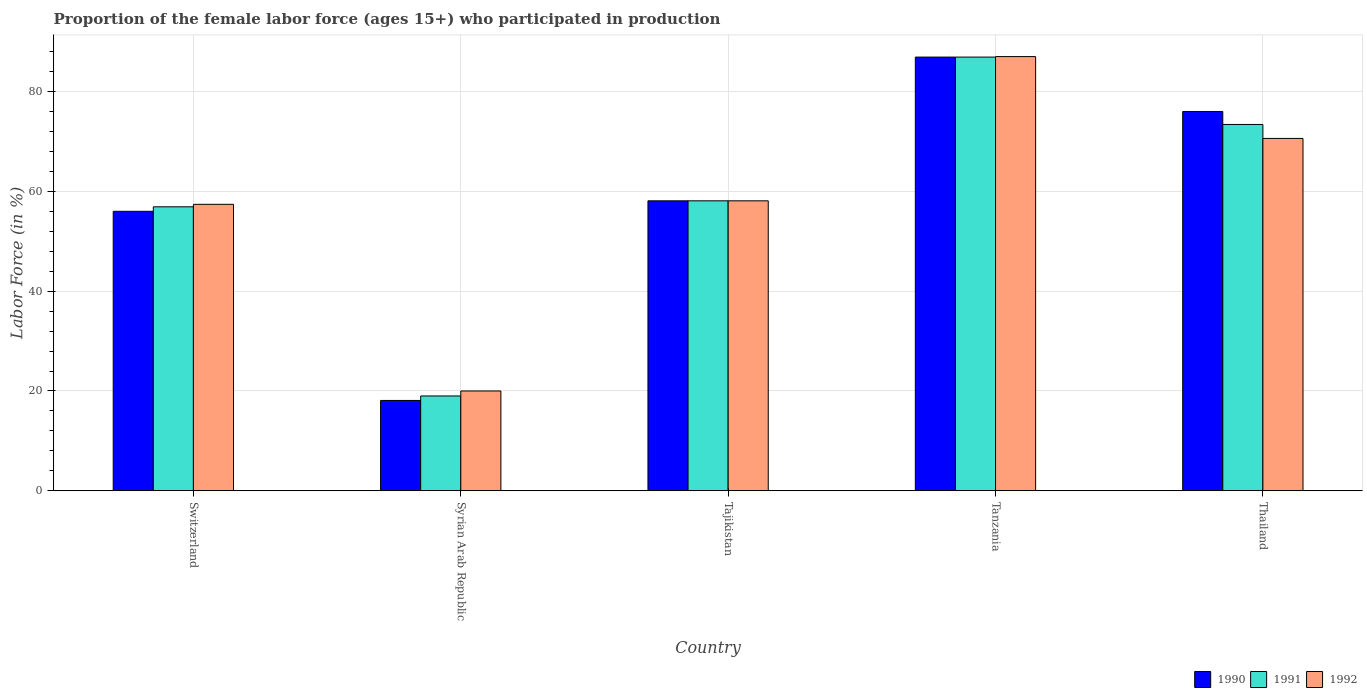How many different coloured bars are there?
Give a very brief answer. 3. How many bars are there on the 2nd tick from the left?
Make the answer very short. 3. How many bars are there on the 5th tick from the right?
Make the answer very short. 3. What is the label of the 3rd group of bars from the left?
Offer a very short reply. Tajikistan. In how many cases, is the number of bars for a given country not equal to the number of legend labels?
Offer a terse response. 0. What is the proportion of the female labor force who participated in production in 1991 in Tanzania?
Ensure brevity in your answer.  86.9. Across all countries, what is the maximum proportion of the female labor force who participated in production in 1990?
Provide a short and direct response. 86.9. Across all countries, what is the minimum proportion of the female labor force who participated in production in 1990?
Your response must be concise. 18.1. In which country was the proportion of the female labor force who participated in production in 1990 maximum?
Give a very brief answer. Tanzania. In which country was the proportion of the female labor force who participated in production in 1991 minimum?
Offer a terse response. Syrian Arab Republic. What is the total proportion of the female labor force who participated in production in 1990 in the graph?
Provide a short and direct response. 295.1. What is the difference between the proportion of the female labor force who participated in production in 1990 in Syrian Arab Republic and that in Thailand?
Your answer should be very brief. -57.9. What is the difference between the proportion of the female labor force who participated in production in 1991 in Thailand and the proportion of the female labor force who participated in production in 1990 in Syrian Arab Republic?
Provide a short and direct response. 55.3. What is the average proportion of the female labor force who participated in production in 1990 per country?
Offer a terse response. 59.02. What is the ratio of the proportion of the female labor force who participated in production in 1992 in Switzerland to that in Thailand?
Keep it short and to the point. 0.81. Is the proportion of the female labor force who participated in production in 1991 in Switzerland less than that in Tanzania?
Your answer should be compact. Yes. What is the difference between the highest and the second highest proportion of the female labor force who participated in production in 1992?
Offer a very short reply. -12.5. What is the difference between the highest and the lowest proportion of the female labor force who participated in production in 1990?
Offer a very short reply. 68.8. In how many countries, is the proportion of the female labor force who participated in production in 1991 greater than the average proportion of the female labor force who participated in production in 1991 taken over all countries?
Offer a terse response. 2. What does the 1st bar from the left in Tajikistan represents?
Ensure brevity in your answer.  1990. Are all the bars in the graph horizontal?
Give a very brief answer. No. Does the graph contain any zero values?
Your response must be concise. No. Does the graph contain grids?
Provide a succinct answer. Yes. What is the title of the graph?
Your answer should be very brief. Proportion of the female labor force (ages 15+) who participated in production. What is the label or title of the X-axis?
Ensure brevity in your answer.  Country. What is the label or title of the Y-axis?
Offer a terse response. Labor Force (in %). What is the Labor Force (in %) in 1990 in Switzerland?
Offer a very short reply. 56. What is the Labor Force (in %) of 1991 in Switzerland?
Offer a terse response. 56.9. What is the Labor Force (in %) in 1992 in Switzerland?
Keep it short and to the point. 57.4. What is the Labor Force (in %) in 1990 in Syrian Arab Republic?
Make the answer very short. 18.1. What is the Labor Force (in %) in 1991 in Syrian Arab Republic?
Ensure brevity in your answer.  19. What is the Labor Force (in %) in 1990 in Tajikistan?
Keep it short and to the point. 58.1. What is the Labor Force (in %) in 1991 in Tajikistan?
Keep it short and to the point. 58.1. What is the Labor Force (in %) in 1992 in Tajikistan?
Make the answer very short. 58.1. What is the Labor Force (in %) of 1990 in Tanzania?
Offer a very short reply. 86.9. What is the Labor Force (in %) in 1991 in Tanzania?
Your answer should be very brief. 86.9. What is the Labor Force (in %) of 1991 in Thailand?
Offer a very short reply. 73.4. What is the Labor Force (in %) in 1992 in Thailand?
Provide a short and direct response. 70.6. Across all countries, what is the maximum Labor Force (in %) in 1990?
Provide a succinct answer. 86.9. Across all countries, what is the maximum Labor Force (in %) in 1991?
Your response must be concise. 86.9. Across all countries, what is the maximum Labor Force (in %) of 1992?
Make the answer very short. 87. Across all countries, what is the minimum Labor Force (in %) of 1990?
Ensure brevity in your answer.  18.1. Across all countries, what is the minimum Labor Force (in %) in 1991?
Offer a terse response. 19. What is the total Labor Force (in %) of 1990 in the graph?
Keep it short and to the point. 295.1. What is the total Labor Force (in %) of 1991 in the graph?
Provide a succinct answer. 294.3. What is the total Labor Force (in %) in 1992 in the graph?
Your answer should be compact. 293.1. What is the difference between the Labor Force (in %) in 1990 in Switzerland and that in Syrian Arab Republic?
Your response must be concise. 37.9. What is the difference between the Labor Force (in %) in 1991 in Switzerland and that in Syrian Arab Republic?
Your answer should be compact. 37.9. What is the difference between the Labor Force (in %) in 1992 in Switzerland and that in Syrian Arab Republic?
Offer a terse response. 37.4. What is the difference between the Labor Force (in %) in 1990 in Switzerland and that in Tanzania?
Offer a terse response. -30.9. What is the difference between the Labor Force (in %) of 1992 in Switzerland and that in Tanzania?
Offer a terse response. -29.6. What is the difference between the Labor Force (in %) in 1991 in Switzerland and that in Thailand?
Keep it short and to the point. -16.5. What is the difference between the Labor Force (in %) of 1991 in Syrian Arab Republic and that in Tajikistan?
Your answer should be compact. -39.1. What is the difference between the Labor Force (in %) of 1992 in Syrian Arab Republic and that in Tajikistan?
Your response must be concise. -38.1. What is the difference between the Labor Force (in %) in 1990 in Syrian Arab Republic and that in Tanzania?
Keep it short and to the point. -68.8. What is the difference between the Labor Force (in %) in 1991 in Syrian Arab Republic and that in Tanzania?
Offer a very short reply. -67.9. What is the difference between the Labor Force (in %) in 1992 in Syrian Arab Republic and that in Tanzania?
Offer a very short reply. -67. What is the difference between the Labor Force (in %) in 1990 in Syrian Arab Republic and that in Thailand?
Your response must be concise. -57.9. What is the difference between the Labor Force (in %) in 1991 in Syrian Arab Republic and that in Thailand?
Your answer should be compact. -54.4. What is the difference between the Labor Force (in %) in 1992 in Syrian Arab Republic and that in Thailand?
Offer a very short reply. -50.6. What is the difference between the Labor Force (in %) in 1990 in Tajikistan and that in Tanzania?
Provide a succinct answer. -28.8. What is the difference between the Labor Force (in %) of 1991 in Tajikistan and that in Tanzania?
Provide a short and direct response. -28.8. What is the difference between the Labor Force (in %) in 1992 in Tajikistan and that in Tanzania?
Give a very brief answer. -28.9. What is the difference between the Labor Force (in %) in 1990 in Tajikistan and that in Thailand?
Give a very brief answer. -17.9. What is the difference between the Labor Force (in %) of 1991 in Tajikistan and that in Thailand?
Offer a very short reply. -15.3. What is the difference between the Labor Force (in %) in 1990 in Tanzania and that in Thailand?
Provide a succinct answer. 10.9. What is the difference between the Labor Force (in %) of 1991 in Tanzania and that in Thailand?
Keep it short and to the point. 13.5. What is the difference between the Labor Force (in %) in 1990 in Switzerland and the Labor Force (in %) in 1992 in Syrian Arab Republic?
Your answer should be compact. 36. What is the difference between the Labor Force (in %) in 1991 in Switzerland and the Labor Force (in %) in 1992 in Syrian Arab Republic?
Offer a very short reply. 36.9. What is the difference between the Labor Force (in %) of 1990 in Switzerland and the Labor Force (in %) of 1991 in Tanzania?
Provide a short and direct response. -30.9. What is the difference between the Labor Force (in %) of 1990 in Switzerland and the Labor Force (in %) of 1992 in Tanzania?
Provide a short and direct response. -31. What is the difference between the Labor Force (in %) of 1991 in Switzerland and the Labor Force (in %) of 1992 in Tanzania?
Offer a terse response. -30.1. What is the difference between the Labor Force (in %) of 1990 in Switzerland and the Labor Force (in %) of 1991 in Thailand?
Give a very brief answer. -17.4. What is the difference between the Labor Force (in %) of 1990 in Switzerland and the Labor Force (in %) of 1992 in Thailand?
Provide a succinct answer. -14.6. What is the difference between the Labor Force (in %) in 1991 in Switzerland and the Labor Force (in %) in 1992 in Thailand?
Your answer should be compact. -13.7. What is the difference between the Labor Force (in %) in 1990 in Syrian Arab Republic and the Labor Force (in %) in 1991 in Tajikistan?
Provide a succinct answer. -40. What is the difference between the Labor Force (in %) of 1991 in Syrian Arab Republic and the Labor Force (in %) of 1992 in Tajikistan?
Offer a terse response. -39.1. What is the difference between the Labor Force (in %) in 1990 in Syrian Arab Republic and the Labor Force (in %) in 1991 in Tanzania?
Keep it short and to the point. -68.8. What is the difference between the Labor Force (in %) of 1990 in Syrian Arab Republic and the Labor Force (in %) of 1992 in Tanzania?
Provide a succinct answer. -68.9. What is the difference between the Labor Force (in %) in 1991 in Syrian Arab Republic and the Labor Force (in %) in 1992 in Tanzania?
Provide a short and direct response. -68. What is the difference between the Labor Force (in %) of 1990 in Syrian Arab Republic and the Labor Force (in %) of 1991 in Thailand?
Give a very brief answer. -55.3. What is the difference between the Labor Force (in %) of 1990 in Syrian Arab Republic and the Labor Force (in %) of 1992 in Thailand?
Provide a short and direct response. -52.5. What is the difference between the Labor Force (in %) of 1991 in Syrian Arab Republic and the Labor Force (in %) of 1992 in Thailand?
Keep it short and to the point. -51.6. What is the difference between the Labor Force (in %) of 1990 in Tajikistan and the Labor Force (in %) of 1991 in Tanzania?
Give a very brief answer. -28.8. What is the difference between the Labor Force (in %) of 1990 in Tajikistan and the Labor Force (in %) of 1992 in Tanzania?
Provide a short and direct response. -28.9. What is the difference between the Labor Force (in %) in 1991 in Tajikistan and the Labor Force (in %) in 1992 in Tanzania?
Give a very brief answer. -28.9. What is the difference between the Labor Force (in %) of 1990 in Tajikistan and the Labor Force (in %) of 1991 in Thailand?
Ensure brevity in your answer.  -15.3. What is the difference between the Labor Force (in %) of 1990 in Tajikistan and the Labor Force (in %) of 1992 in Thailand?
Your response must be concise. -12.5. What is the difference between the Labor Force (in %) in 1991 in Tajikistan and the Labor Force (in %) in 1992 in Thailand?
Your response must be concise. -12.5. What is the difference between the Labor Force (in %) of 1990 in Tanzania and the Labor Force (in %) of 1991 in Thailand?
Provide a succinct answer. 13.5. What is the difference between the Labor Force (in %) in 1990 in Tanzania and the Labor Force (in %) in 1992 in Thailand?
Offer a terse response. 16.3. What is the difference between the Labor Force (in %) of 1991 in Tanzania and the Labor Force (in %) of 1992 in Thailand?
Give a very brief answer. 16.3. What is the average Labor Force (in %) in 1990 per country?
Provide a short and direct response. 59.02. What is the average Labor Force (in %) in 1991 per country?
Make the answer very short. 58.86. What is the average Labor Force (in %) in 1992 per country?
Give a very brief answer. 58.62. What is the difference between the Labor Force (in %) in 1990 and Labor Force (in %) in 1991 in Switzerland?
Your answer should be very brief. -0.9. What is the difference between the Labor Force (in %) in 1990 and Labor Force (in %) in 1992 in Switzerland?
Your response must be concise. -1.4. What is the difference between the Labor Force (in %) of 1991 and Labor Force (in %) of 1992 in Switzerland?
Offer a very short reply. -0.5. What is the difference between the Labor Force (in %) of 1990 and Labor Force (in %) of 1992 in Syrian Arab Republic?
Keep it short and to the point. -1.9. What is the difference between the Labor Force (in %) of 1990 and Labor Force (in %) of 1992 in Tajikistan?
Offer a very short reply. 0. What is the difference between the Labor Force (in %) of 1991 and Labor Force (in %) of 1992 in Tajikistan?
Ensure brevity in your answer.  0. What is the difference between the Labor Force (in %) in 1990 and Labor Force (in %) in 1991 in Tanzania?
Your response must be concise. 0. What is the ratio of the Labor Force (in %) in 1990 in Switzerland to that in Syrian Arab Republic?
Give a very brief answer. 3.09. What is the ratio of the Labor Force (in %) of 1991 in Switzerland to that in Syrian Arab Republic?
Your response must be concise. 2.99. What is the ratio of the Labor Force (in %) in 1992 in Switzerland to that in Syrian Arab Republic?
Give a very brief answer. 2.87. What is the ratio of the Labor Force (in %) in 1990 in Switzerland to that in Tajikistan?
Your response must be concise. 0.96. What is the ratio of the Labor Force (in %) of 1991 in Switzerland to that in Tajikistan?
Offer a very short reply. 0.98. What is the ratio of the Labor Force (in %) in 1992 in Switzerland to that in Tajikistan?
Your answer should be compact. 0.99. What is the ratio of the Labor Force (in %) of 1990 in Switzerland to that in Tanzania?
Your response must be concise. 0.64. What is the ratio of the Labor Force (in %) in 1991 in Switzerland to that in Tanzania?
Offer a very short reply. 0.65. What is the ratio of the Labor Force (in %) of 1992 in Switzerland to that in Tanzania?
Keep it short and to the point. 0.66. What is the ratio of the Labor Force (in %) in 1990 in Switzerland to that in Thailand?
Give a very brief answer. 0.74. What is the ratio of the Labor Force (in %) in 1991 in Switzerland to that in Thailand?
Offer a terse response. 0.78. What is the ratio of the Labor Force (in %) of 1992 in Switzerland to that in Thailand?
Give a very brief answer. 0.81. What is the ratio of the Labor Force (in %) of 1990 in Syrian Arab Republic to that in Tajikistan?
Keep it short and to the point. 0.31. What is the ratio of the Labor Force (in %) in 1991 in Syrian Arab Republic to that in Tajikistan?
Provide a succinct answer. 0.33. What is the ratio of the Labor Force (in %) in 1992 in Syrian Arab Republic to that in Tajikistan?
Your answer should be very brief. 0.34. What is the ratio of the Labor Force (in %) in 1990 in Syrian Arab Republic to that in Tanzania?
Provide a succinct answer. 0.21. What is the ratio of the Labor Force (in %) of 1991 in Syrian Arab Republic to that in Tanzania?
Offer a very short reply. 0.22. What is the ratio of the Labor Force (in %) of 1992 in Syrian Arab Republic to that in Tanzania?
Give a very brief answer. 0.23. What is the ratio of the Labor Force (in %) of 1990 in Syrian Arab Republic to that in Thailand?
Offer a very short reply. 0.24. What is the ratio of the Labor Force (in %) in 1991 in Syrian Arab Republic to that in Thailand?
Ensure brevity in your answer.  0.26. What is the ratio of the Labor Force (in %) in 1992 in Syrian Arab Republic to that in Thailand?
Keep it short and to the point. 0.28. What is the ratio of the Labor Force (in %) in 1990 in Tajikistan to that in Tanzania?
Provide a short and direct response. 0.67. What is the ratio of the Labor Force (in %) in 1991 in Tajikistan to that in Tanzania?
Your answer should be compact. 0.67. What is the ratio of the Labor Force (in %) in 1992 in Tajikistan to that in Tanzania?
Your response must be concise. 0.67. What is the ratio of the Labor Force (in %) in 1990 in Tajikistan to that in Thailand?
Your response must be concise. 0.76. What is the ratio of the Labor Force (in %) in 1991 in Tajikistan to that in Thailand?
Offer a terse response. 0.79. What is the ratio of the Labor Force (in %) in 1992 in Tajikistan to that in Thailand?
Your answer should be very brief. 0.82. What is the ratio of the Labor Force (in %) in 1990 in Tanzania to that in Thailand?
Offer a very short reply. 1.14. What is the ratio of the Labor Force (in %) in 1991 in Tanzania to that in Thailand?
Offer a very short reply. 1.18. What is the ratio of the Labor Force (in %) in 1992 in Tanzania to that in Thailand?
Your response must be concise. 1.23. What is the difference between the highest and the second highest Labor Force (in %) of 1990?
Your answer should be compact. 10.9. What is the difference between the highest and the second highest Labor Force (in %) of 1991?
Your answer should be compact. 13.5. What is the difference between the highest and the second highest Labor Force (in %) of 1992?
Your answer should be compact. 16.4. What is the difference between the highest and the lowest Labor Force (in %) of 1990?
Provide a succinct answer. 68.8. What is the difference between the highest and the lowest Labor Force (in %) in 1991?
Your response must be concise. 67.9. What is the difference between the highest and the lowest Labor Force (in %) in 1992?
Your answer should be very brief. 67. 